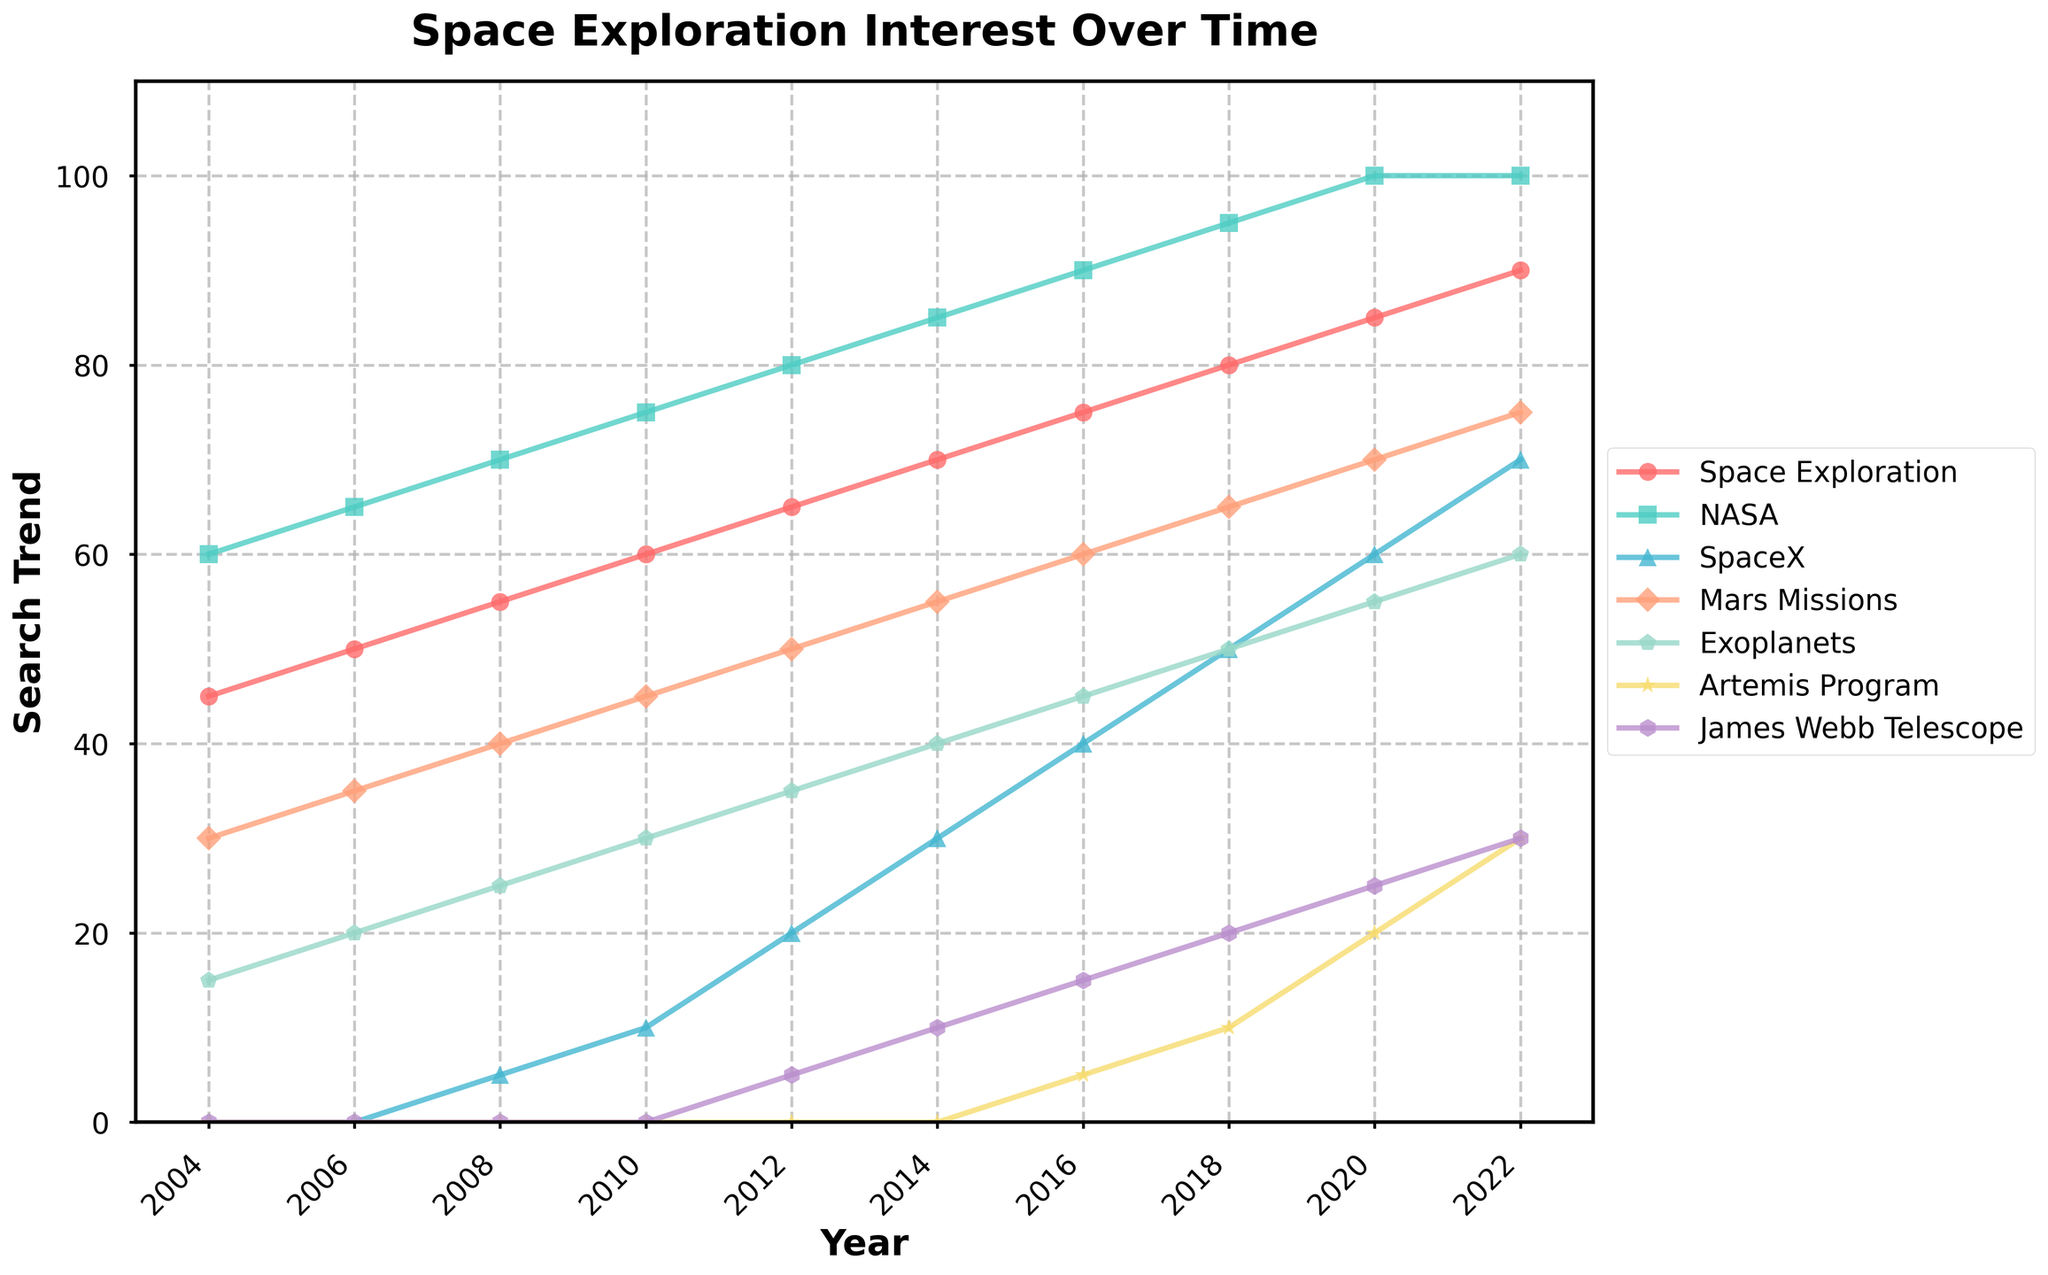What year did "Space Exploration" reach its highest search trend? By observing the "Space Exploration" line in the figure, note the highest point, which occurs in 2022.
Answer: 2022 Which category showed the greatest increase in search trend from 2004 to 2022? Compare the change in search trend for each category by subtracting the 2004 value from the 2022 value. The highest change is for "SpaceX," increasing from 0 to 70.
Answer: SpaceX What is the combined trend value of "James Webb Telescope" and "Mars Missions" in 2020? Locate the "James Webb Telescope" and "Mars Missions" data points for 2020, which are 25 and 70 respectively, then add them: 25 + 70.
Answer: 95 Between 2010 and 2016, which category had the smallest increase in search trend? Calculate the increase for each category between 2010 and 2016 and find the smallest: "Space Exploration" increased by 15, "NASA" by 15, "SpaceX" by 30, "Mars Missions" by 15, "Exoplanets" by 15, "Artemis Program" by 5, "James Webb Telescope" by 15. The smallest increase is for "Artemis Program."
Answer: Artemis Program Which two categories had equal search trend values in 2022? Check all the data points for 2022 and identify which two are equal: "NASA" and "SpaceX" both have a value of 100.
Answer: NASA and SpaceX What is the difference in search trend for "Exoplanets" between 2008 and 2010? Subtract the "Exoplanets" value in 2008 from its value in 2010: 30 - 25.
Answer: 5 What is the average search trend for "Artemis Program" across all the years it has data? Sum up all the "Artemis Program" values and divide by the number of years with data: (5 + 10 + 20 + 30) / 4.
Answer: 16.25 In 2016, which category had the highest search trend? Compare all categories' values for 2016; "NASA" has the highest with 90.
Answer: NASA What is the total trend value for all categories in the year 2018? Sum up all the values for 2018: 80 (Space Exploration) + 95 (NASA) + 50 (SpaceX) + 65 (Mars Missions) + 50 (Exoplanets) + 10 (Artemis Program) + 20 (James Webb Telescope).
Answer: 370 What is the ratio of the search trend of "Mars Missions" to "James Webb Telescope" in 2020? Divide the value for "Mars Missions" by the value for "James Webb Telescope" in 2020: 70 / 25.
Answer: 2.8 